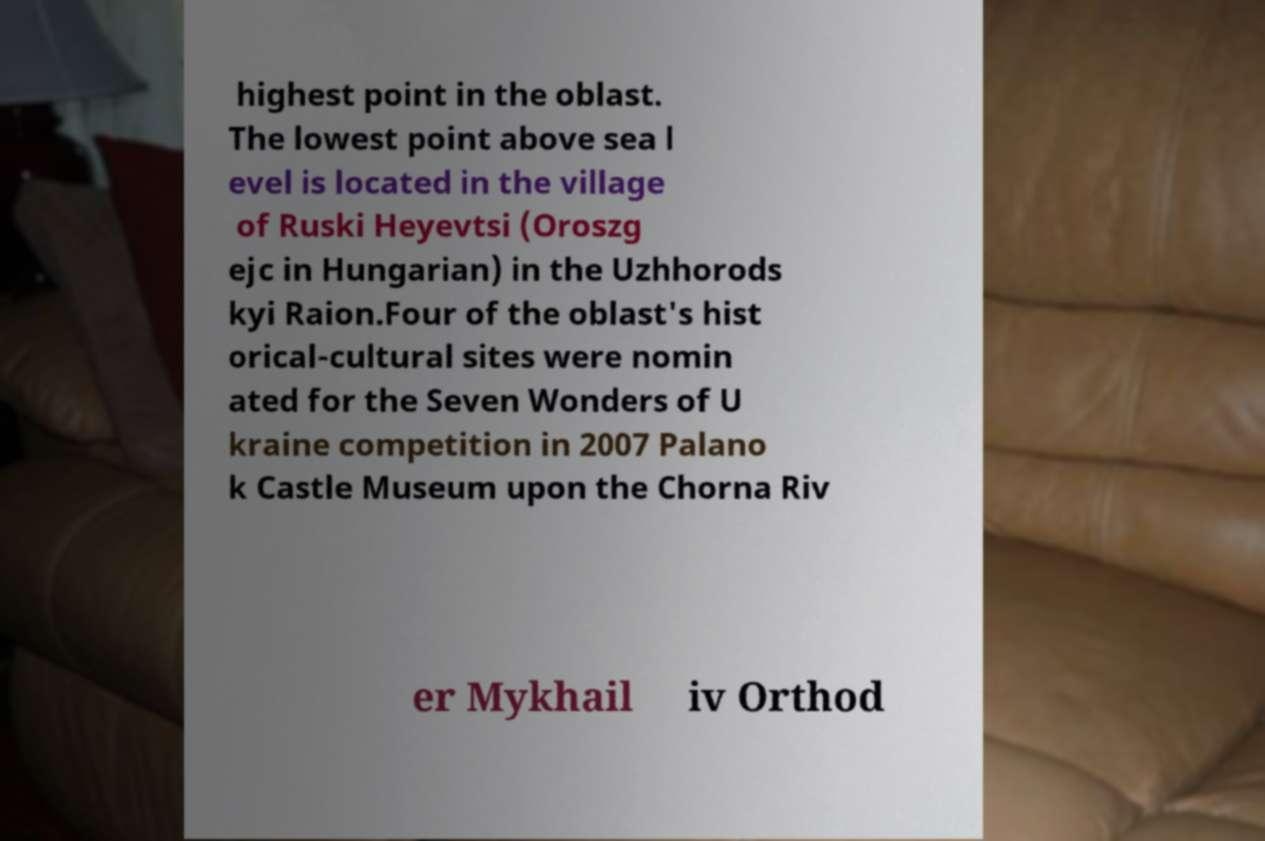Please identify and transcribe the text found in this image. highest point in the oblast. The lowest point above sea l evel is located in the village of Ruski Heyevtsi (Oroszg ejc in Hungarian) in the Uzhhorods kyi Raion.Four of the oblast's hist orical-cultural sites were nomin ated for the Seven Wonders of U kraine competition in 2007 Palano k Castle Museum upon the Chorna Riv er Mykhail iv Orthod 